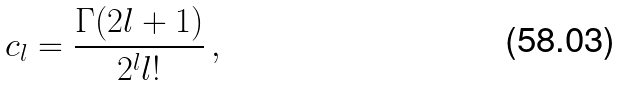Convert formula to latex. <formula><loc_0><loc_0><loc_500><loc_500>c _ { l } = \frac { \Gamma ( 2 l + 1 ) } { 2 ^ { l } l ! } \, ,</formula> 